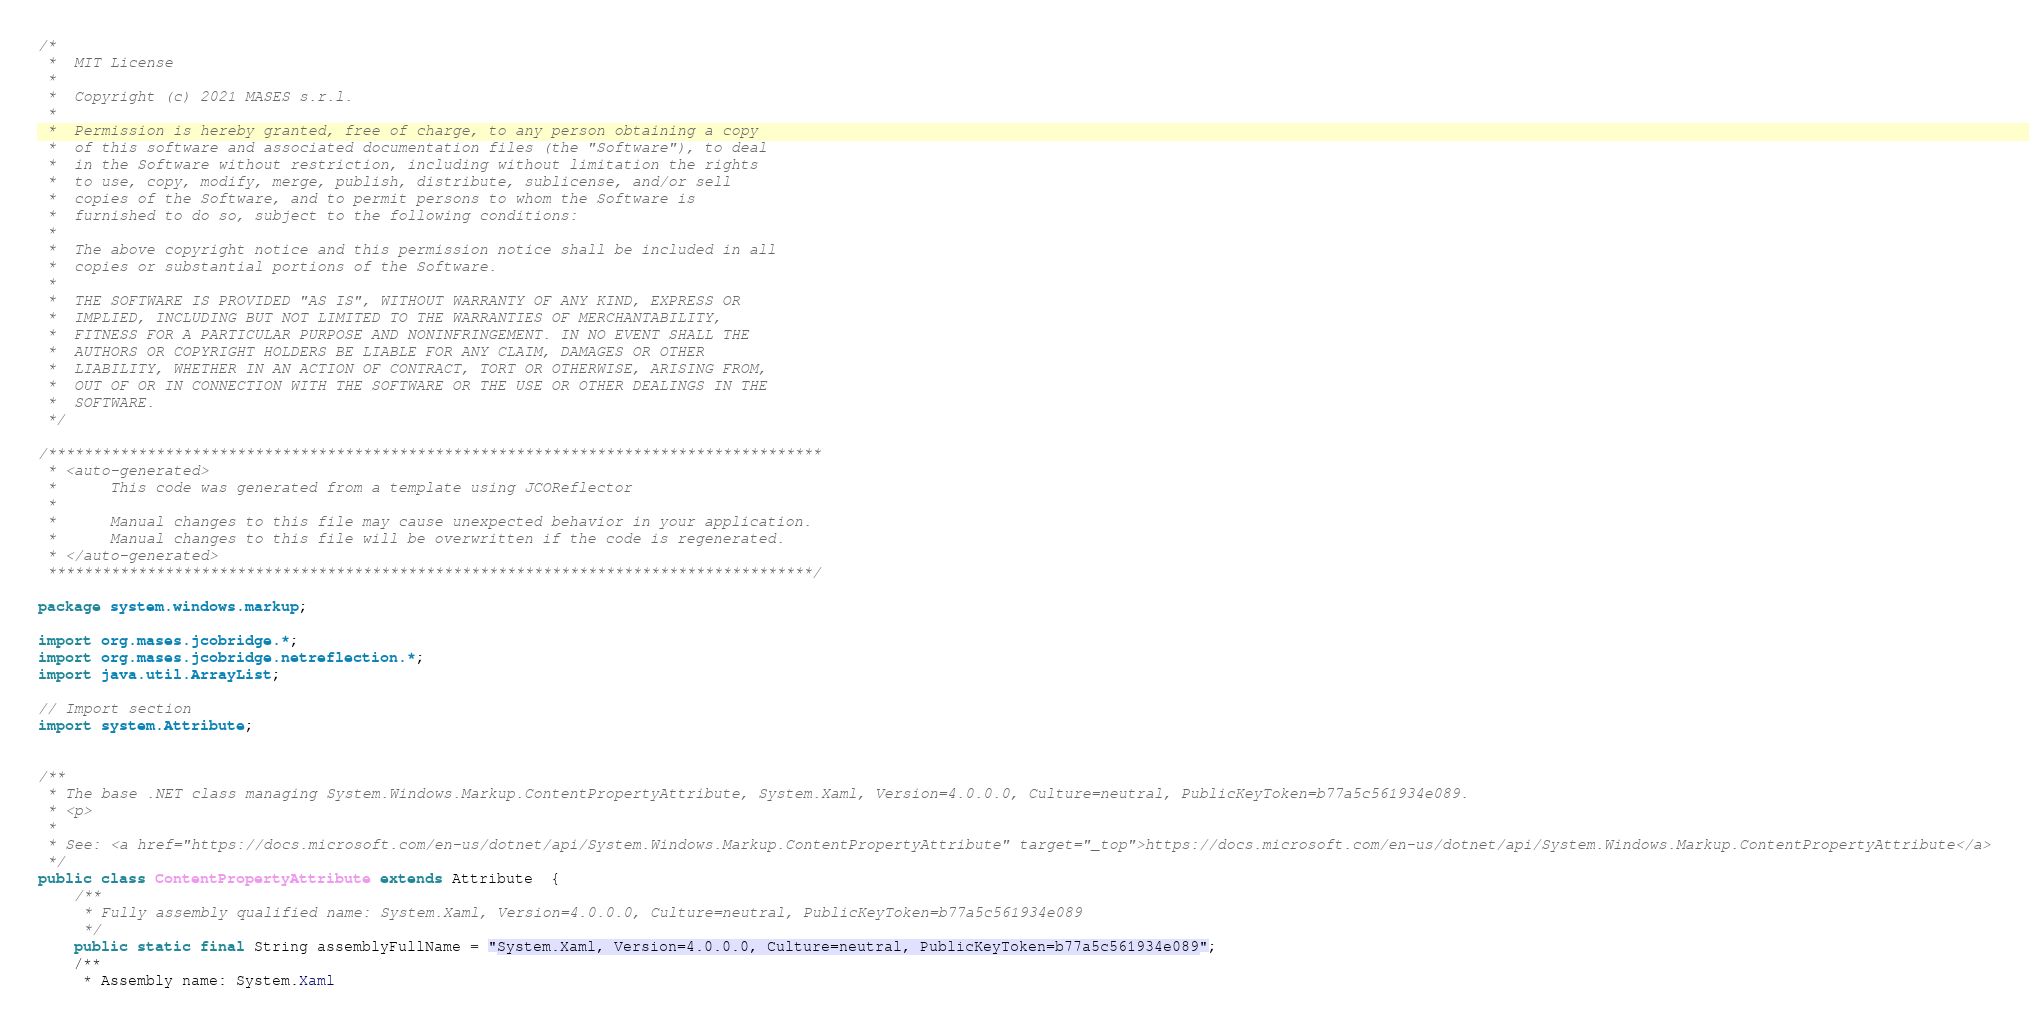<code> <loc_0><loc_0><loc_500><loc_500><_Java_>/*
 *  MIT License
 *
 *  Copyright (c) 2021 MASES s.r.l.
 *
 *  Permission is hereby granted, free of charge, to any person obtaining a copy
 *  of this software and associated documentation files (the "Software"), to deal
 *  in the Software without restriction, including without limitation the rights
 *  to use, copy, modify, merge, publish, distribute, sublicense, and/or sell
 *  copies of the Software, and to permit persons to whom the Software is
 *  furnished to do so, subject to the following conditions:
 *
 *  The above copyright notice and this permission notice shall be included in all
 *  copies or substantial portions of the Software.
 *
 *  THE SOFTWARE IS PROVIDED "AS IS", WITHOUT WARRANTY OF ANY KIND, EXPRESS OR
 *  IMPLIED, INCLUDING BUT NOT LIMITED TO THE WARRANTIES OF MERCHANTABILITY,
 *  FITNESS FOR A PARTICULAR PURPOSE AND NONINFRINGEMENT. IN NO EVENT SHALL THE
 *  AUTHORS OR COPYRIGHT HOLDERS BE LIABLE FOR ANY CLAIM, DAMAGES OR OTHER
 *  LIABILITY, WHETHER IN AN ACTION OF CONTRACT, TORT OR OTHERWISE, ARISING FROM,
 *  OUT OF OR IN CONNECTION WITH THE SOFTWARE OR THE USE OR OTHER DEALINGS IN THE
 *  SOFTWARE.
 */

/**************************************************************************************
 * <auto-generated>
 *      This code was generated from a template using JCOReflector
 * 
 *      Manual changes to this file may cause unexpected behavior in your application.
 *      Manual changes to this file will be overwritten if the code is regenerated.
 * </auto-generated>
 *************************************************************************************/

package system.windows.markup;

import org.mases.jcobridge.*;
import org.mases.jcobridge.netreflection.*;
import java.util.ArrayList;

// Import section
import system.Attribute;


/**
 * The base .NET class managing System.Windows.Markup.ContentPropertyAttribute, System.Xaml, Version=4.0.0.0, Culture=neutral, PublicKeyToken=b77a5c561934e089.
 * <p>
 * 
 * See: <a href="https://docs.microsoft.com/en-us/dotnet/api/System.Windows.Markup.ContentPropertyAttribute" target="_top">https://docs.microsoft.com/en-us/dotnet/api/System.Windows.Markup.ContentPropertyAttribute</a>
 */
public class ContentPropertyAttribute extends Attribute  {
    /**
     * Fully assembly qualified name: System.Xaml, Version=4.0.0.0, Culture=neutral, PublicKeyToken=b77a5c561934e089
     */
    public static final String assemblyFullName = "System.Xaml, Version=4.0.0.0, Culture=neutral, PublicKeyToken=b77a5c561934e089";
    /**
     * Assembly name: System.Xaml</code> 